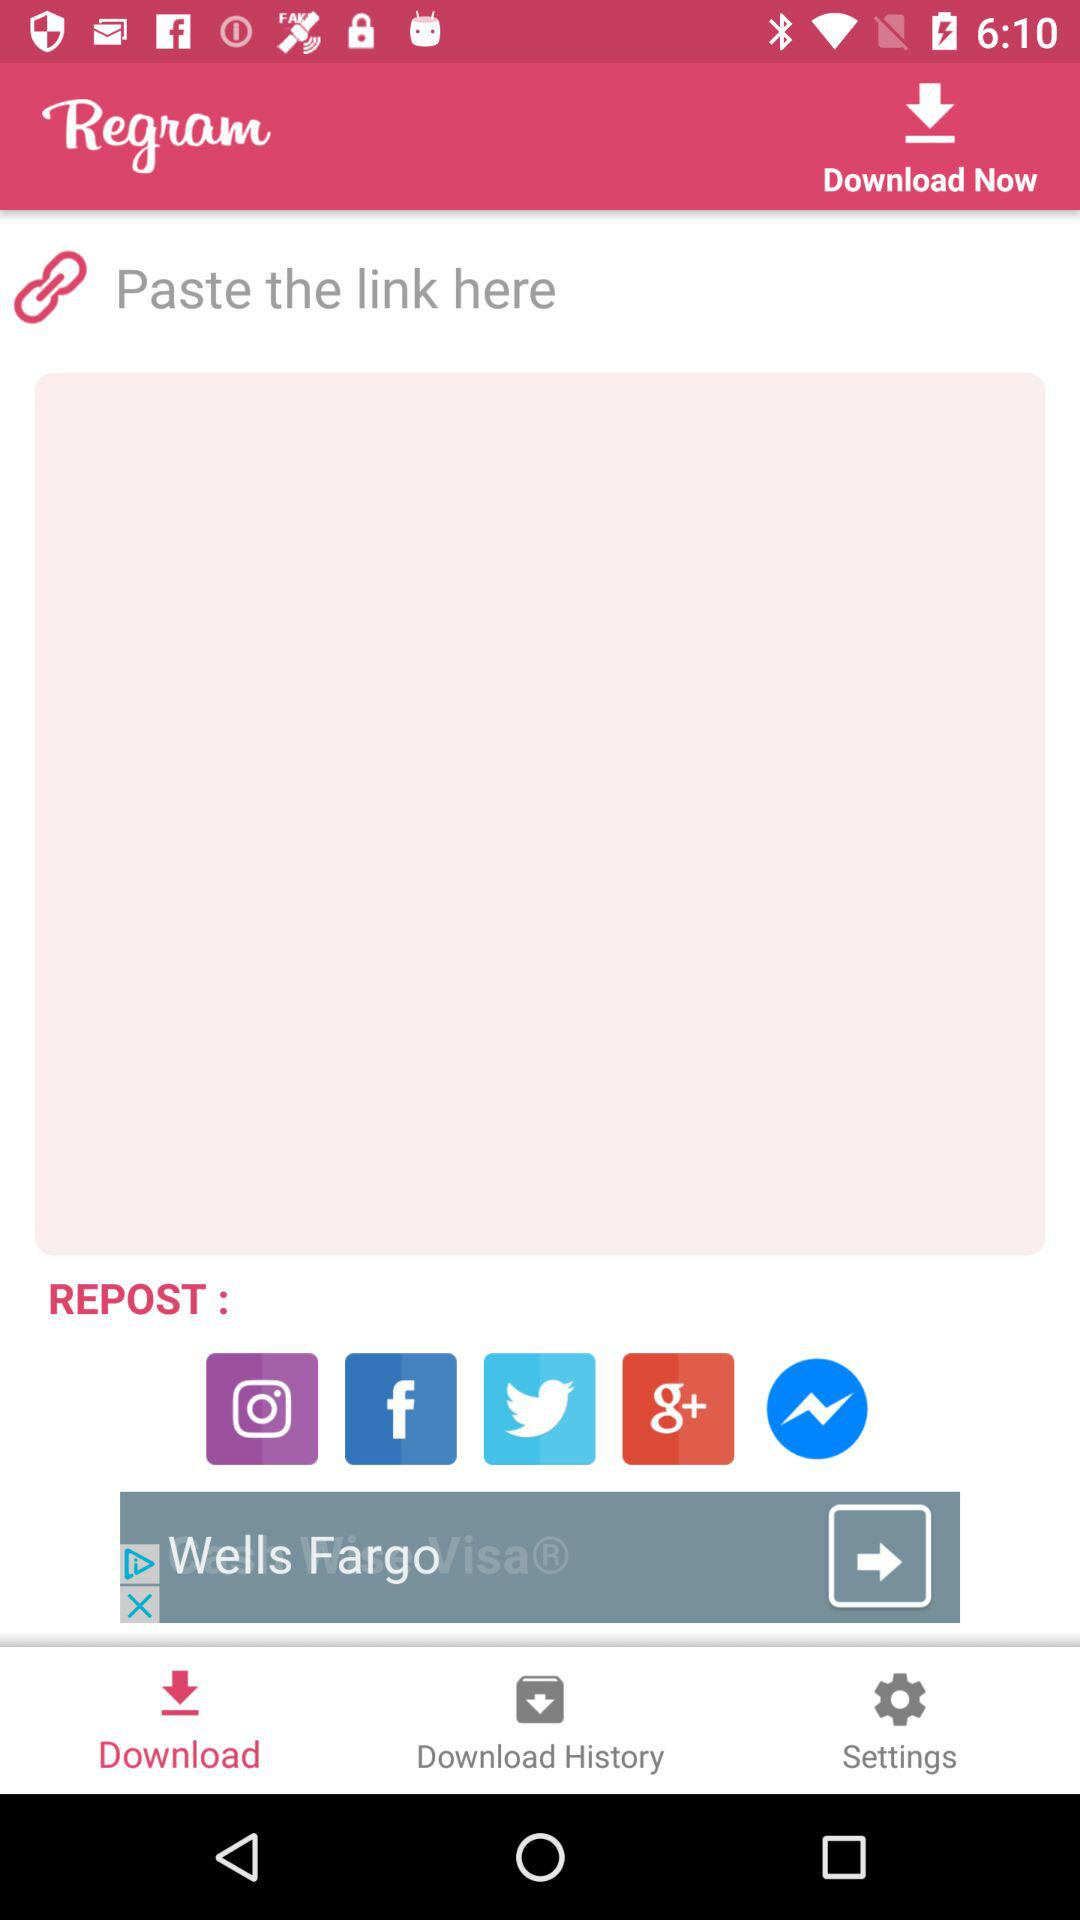Through what accounts can content be reposted? The content can be reposted through "Instagram", "Facebook", "Twitter", "Google plus" and "Messenger". 